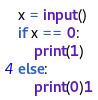Convert code to text. <code><loc_0><loc_0><loc_500><loc_500><_Python_>x = input()
if x == 0:
    print(1)
else:
    print(0)1</code> 